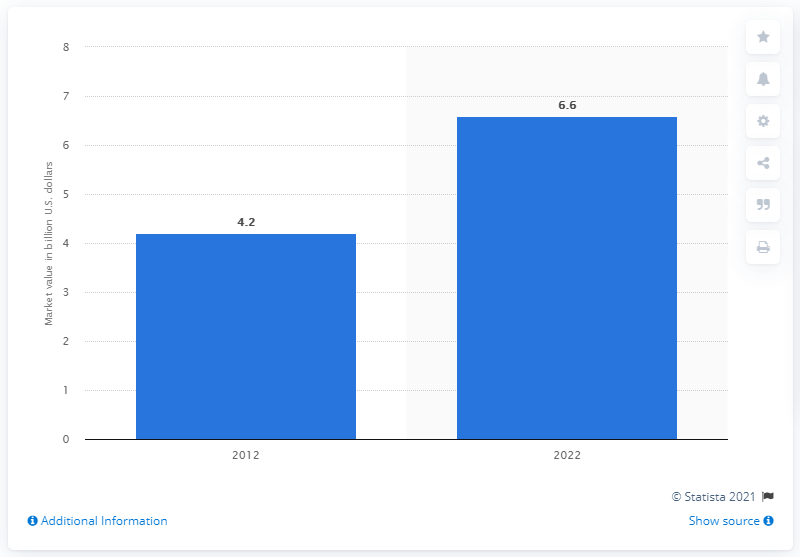Highlight a few significant elements in this photo. It is estimated that approximately 4.2 million individuals in the United States currently suffer from Inflammatory Bowel Disease (IBD). The global ulcerative colitis market is forecasted for the year 2022. In 2012, the global market for ulcerative colitis was valued at approximately $4.2 billion. 